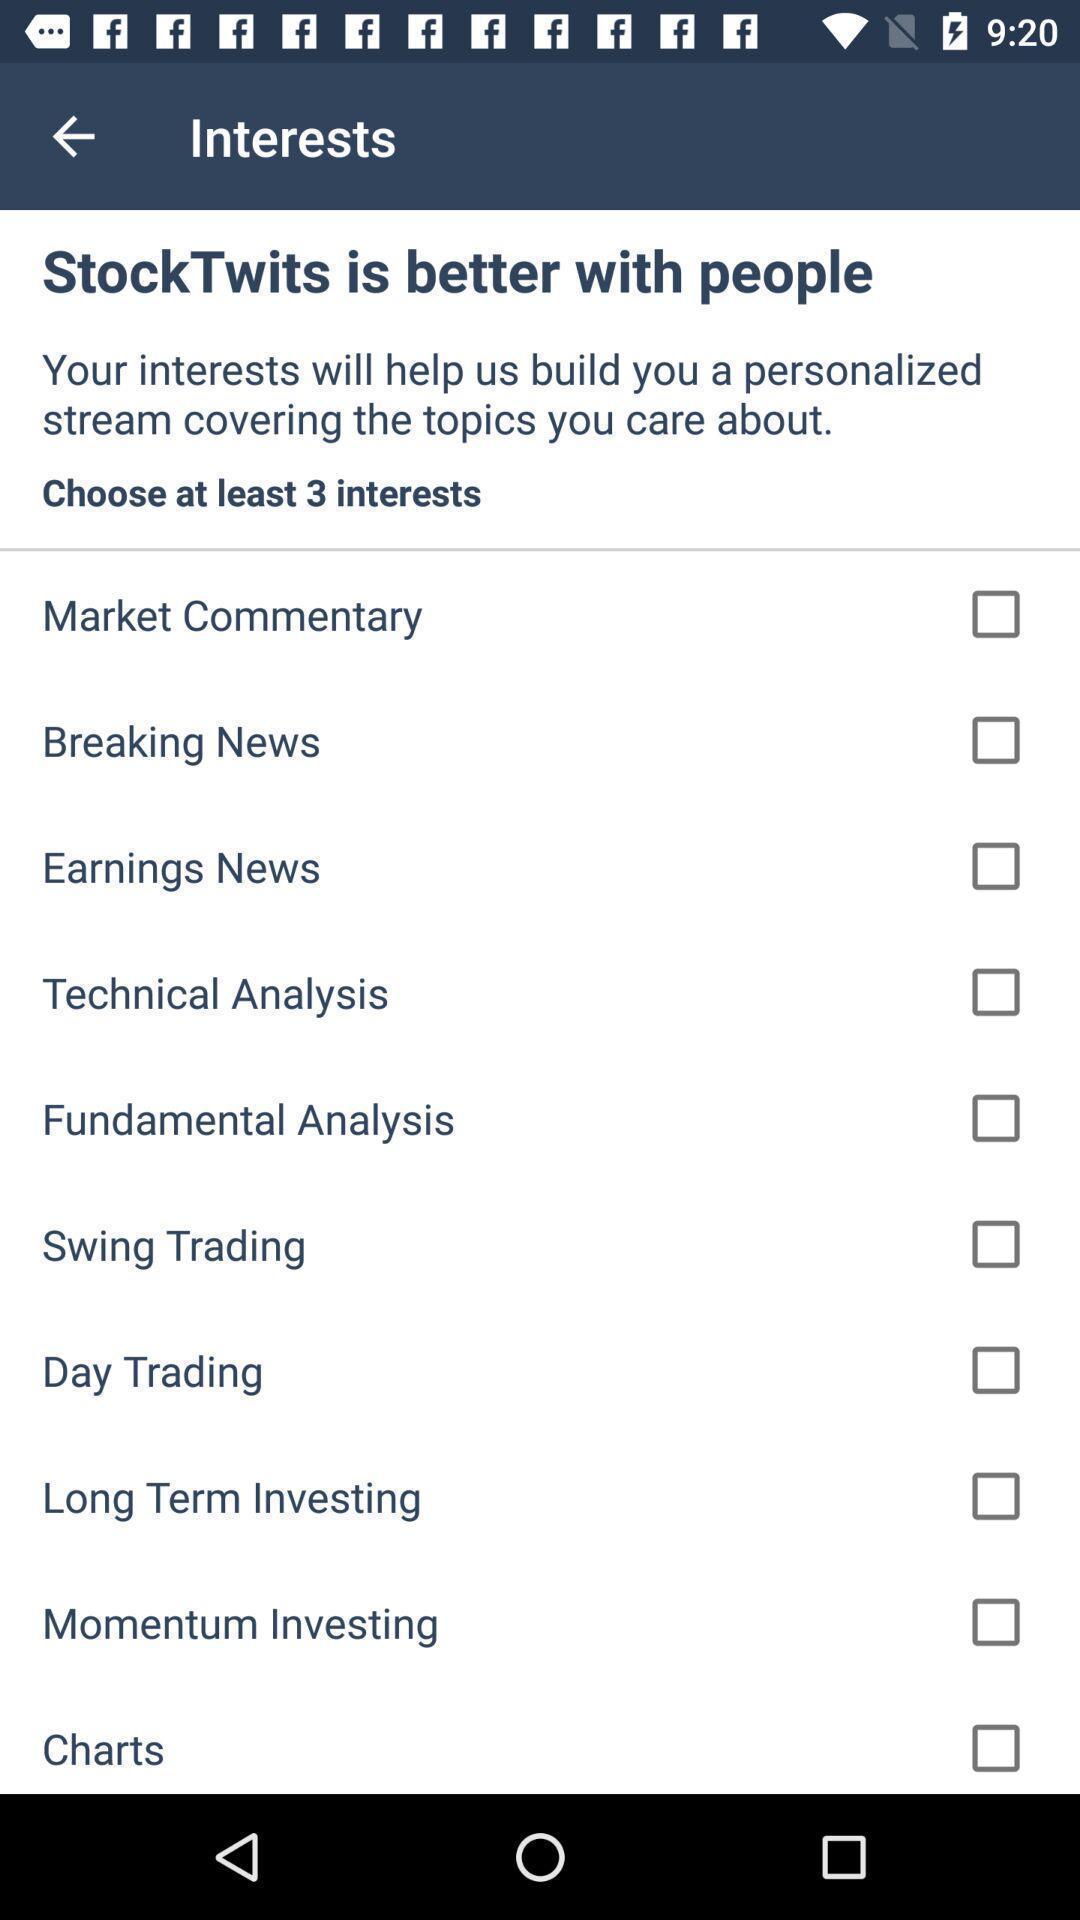Give me a summary of this screen capture. Page displaying various options to select in trading app. 